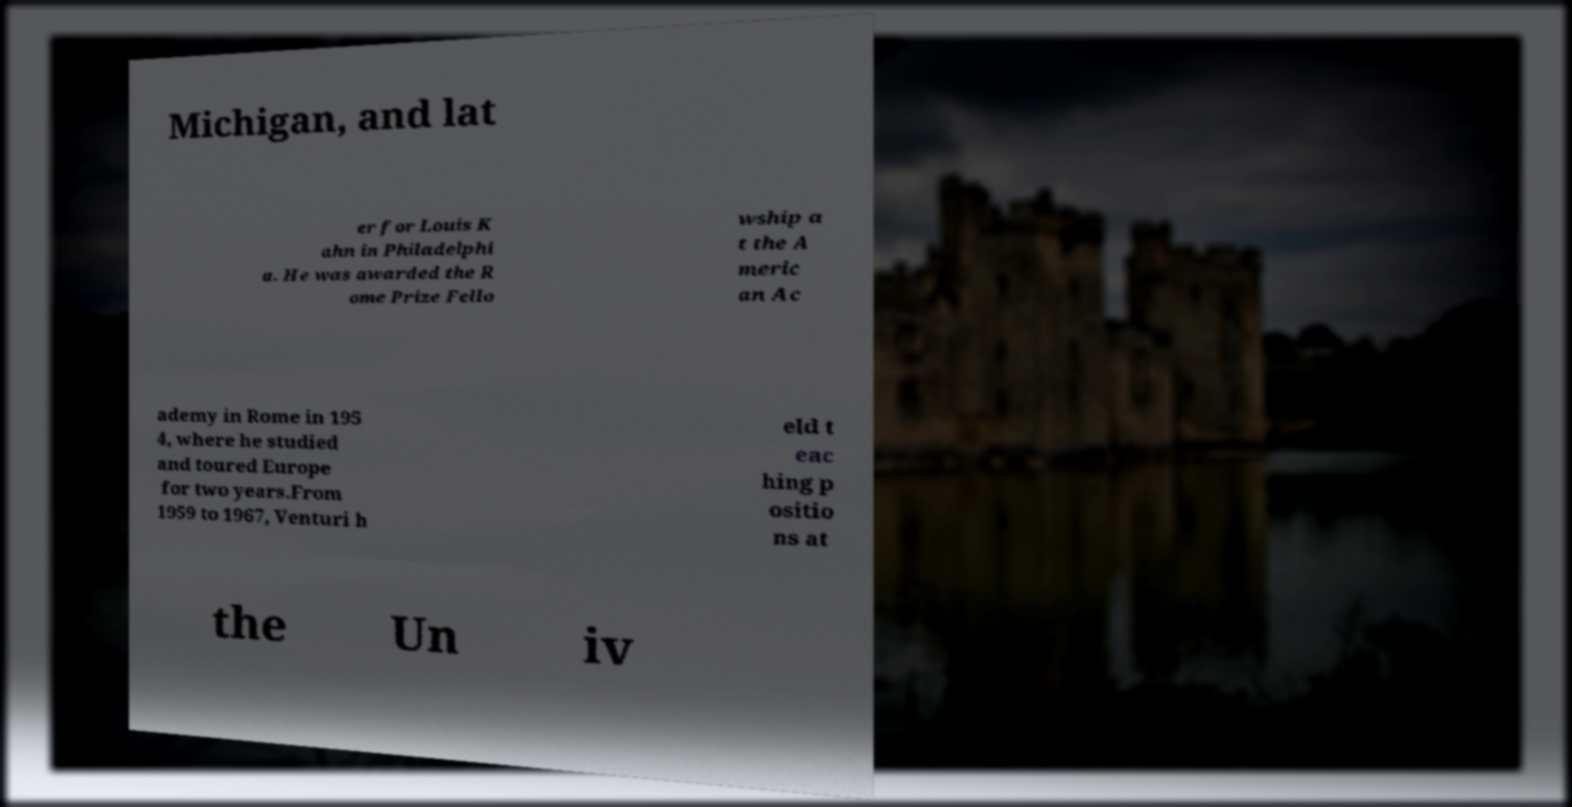Can you read and provide the text displayed in the image?This photo seems to have some interesting text. Can you extract and type it out for me? Michigan, and lat er for Louis K ahn in Philadelphi a. He was awarded the R ome Prize Fello wship a t the A meric an Ac ademy in Rome in 195 4, where he studied and toured Europe for two years.From 1959 to 1967, Venturi h eld t eac hing p ositio ns at the Un iv 